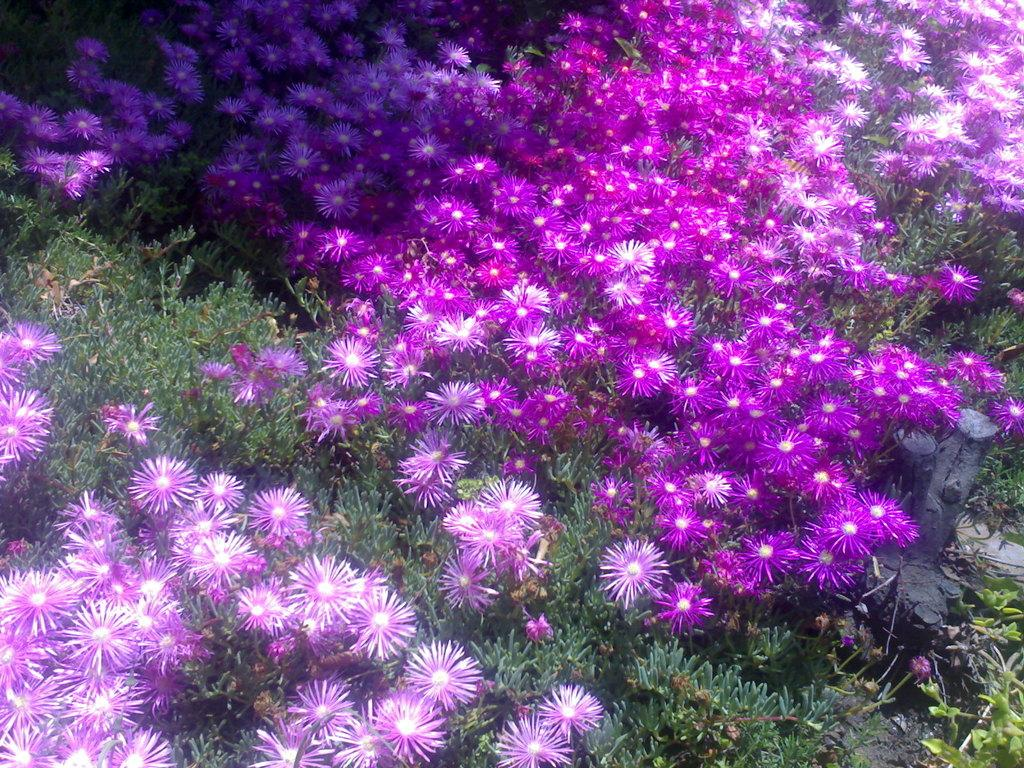What type of vegetation can be seen in the image? There are flowers, plants, and grass visible in the image. Is there any water present in the image? Yes, there is water visible in the image. What is the temper of the flowers in the image? The temper of the flowers cannot be determined from the image, as flowers do not have emotions or temperament. 